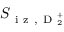Convert formula to latex. <formula><loc_0><loc_0><loc_500><loc_500>S _ { i z , D _ { 2 } ^ { + } }</formula> 